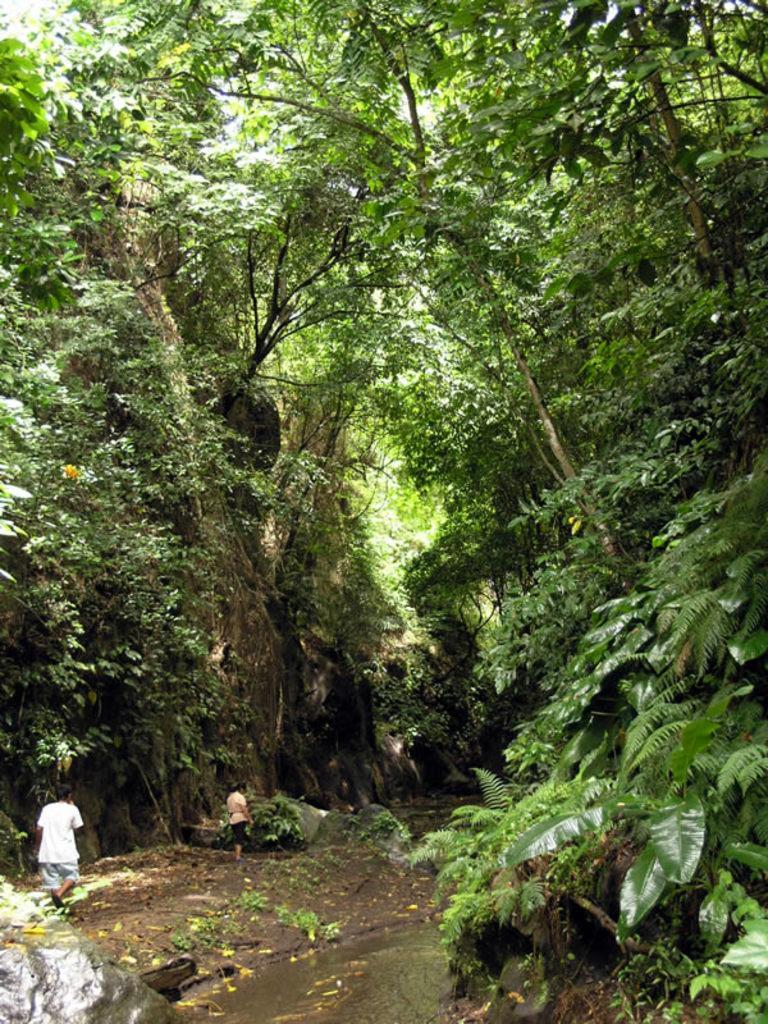Could you give a brief overview of what you see in this image? In the foreground, I can see two persons on the ground and water. In the background, I can see trees, grass, rock and the sky. This image is taken, maybe during a day. 